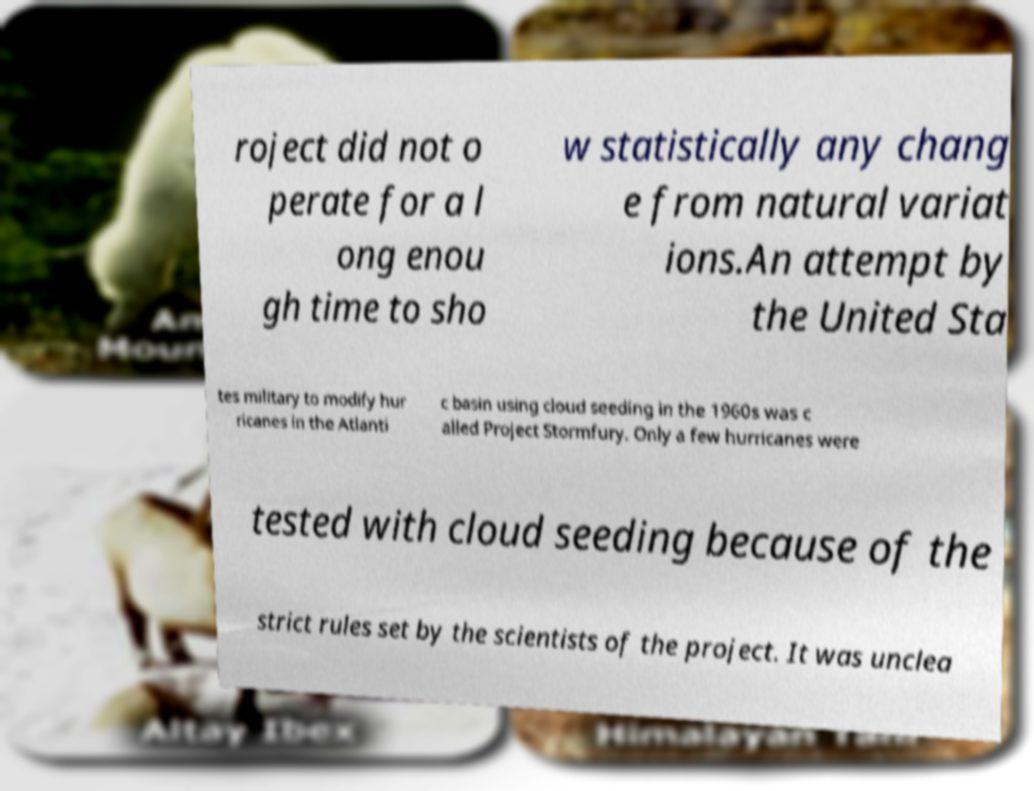Can you read and provide the text displayed in the image?This photo seems to have some interesting text. Can you extract and type it out for me? roject did not o perate for a l ong enou gh time to sho w statistically any chang e from natural variat ions.An attempt by the United Sta tes military to modify hur ricanes in the Atlanti c basin using cloud seeding in the 1960s was c alled Project Stormfury. Only a few hurricanes were tested with cloud seeding because of the strict rules set by the scientists of the project. It was unclea 